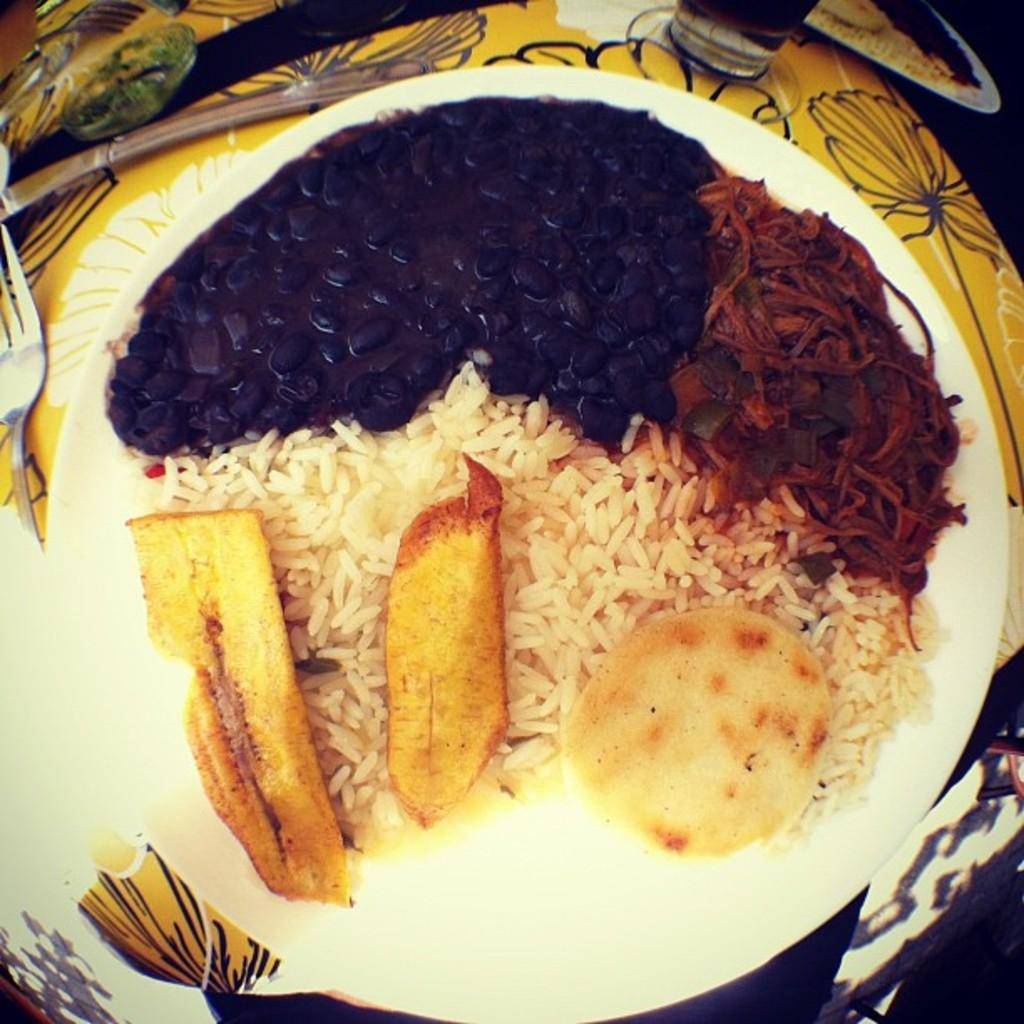What is placed on the plate in the image? There are eatable things placed in a plate. What utensils can be seen in the image? Spoons are visible in the image. What type of container is on the table? There is a glass on the table. What direction does the voice come from in the image? There is no voice present in the image, so it cannot be determined from which direction it would come. 